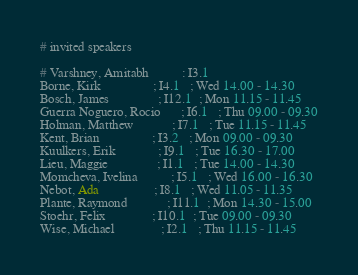<code> <loc_0><loc_0><loc_500><loc_500><_SQL_># invited speakers

# Varshney, Amitabh          : I3.1
Borne, Kirk                ; I4.1   ; Wed 14.00 - 14.30
Bosch, James               ; I12.1  ; Mon 11.15 - 11.45
Guerra Noguero, Rocio      ; I6.1   ; Thu 09.00 - 09.30
Holman, Matthew            ; I7.1   ; Tue 11.15 - 11.45
Kent, Brian                ; I3.2   ; Mon 09.00 - 09.30
Kuulkers, Erik             ; I9.1   ; Tue 16.30 - 17.00
Lieu, Maggie               ; I1.1   ; Tue 14.00 - 14.30
Momcheva, Ivelina          ; I5.1   ; Wed 16.00 - 16.30
Nebot, Ada                 ; I8.1   ; Wed 11.05 - 11.35
Plante, Raymond            ; I11.1  ; Mon 14.30 - 15.00
Stoehr, Felix              ; I10.1  ; Tue 09.00 - 09.30
Wise, Michael              ; I2.1   ; Thu 11.15 - 11.45

</code> 